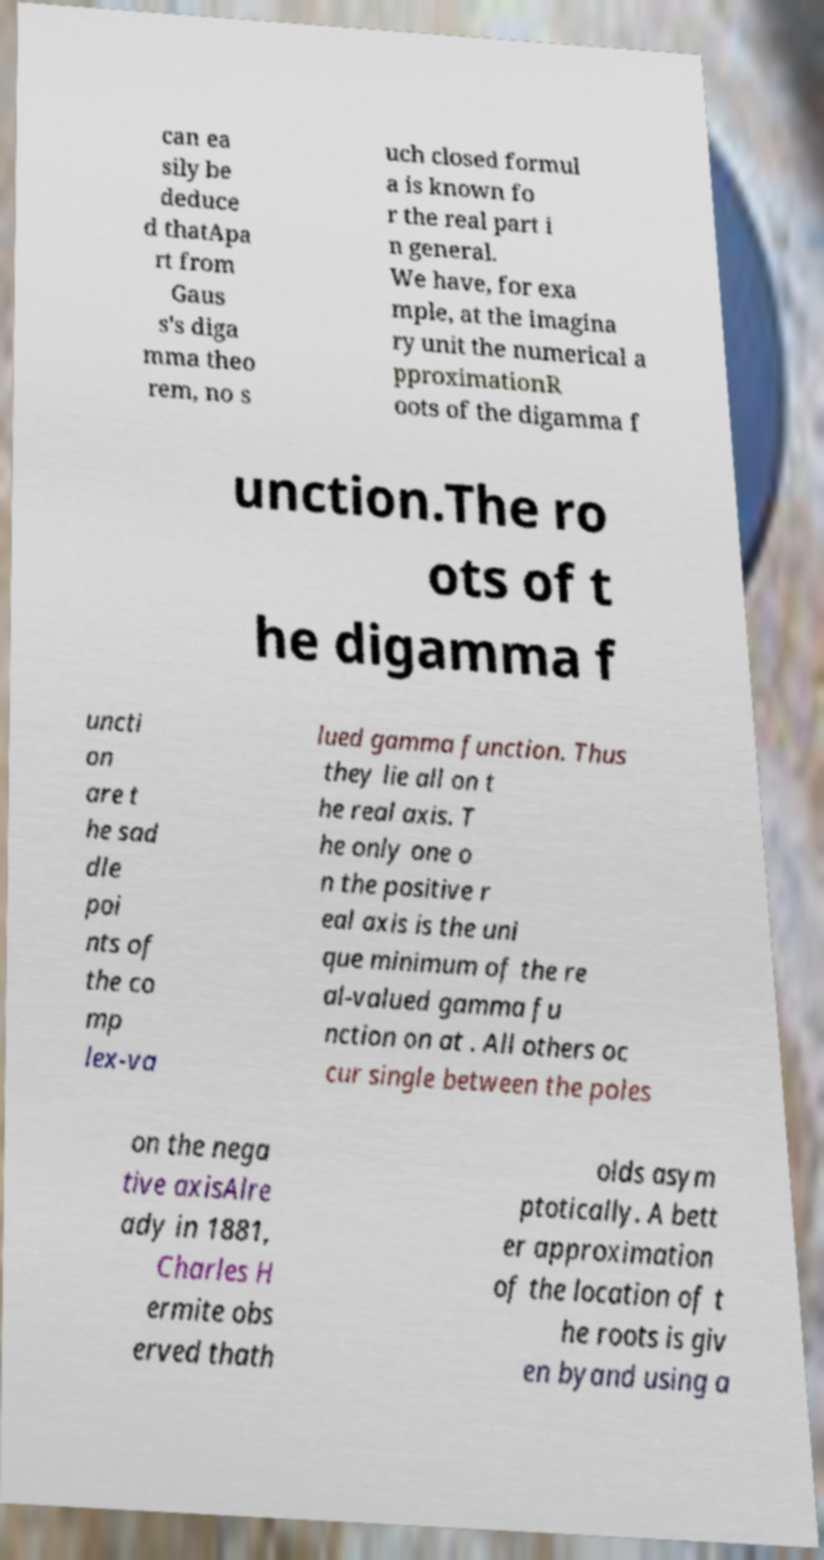What messages or text are displayed in this image? I need them in a readable, typed format. can ea sily be deduce d thatApa rt from Gaus s's diga mma theo rem, no s uch closed formul a is known fo r the real part i n general. We have, for exa mple, at the imagina ry unit the numerical a pproximationR oots of the digamma f unction.The ro ots of t he digamma f uncti on are t he sad dle poi nts of the co mp lex-va lued gamma function. Thus they lie all on t he real axis. T he only one o n the positive r eal axis is the uni que minimum of the re al-valued gamma fu nction on at . All others oc cur single between the poles on the nega tive axisAlre ady in 1881, Charles H ermite obs erved thath olds asym ptotically. A bett er approximation of the location of t he roots is giv en byand using a 